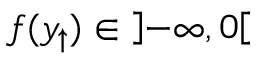Convert formula to latex. <formula><loc_0><loc_0><loc_500><loc_500>f ( y _ { \uparrow } ) \in \left ] - \infty , 0 \right [</formula> 